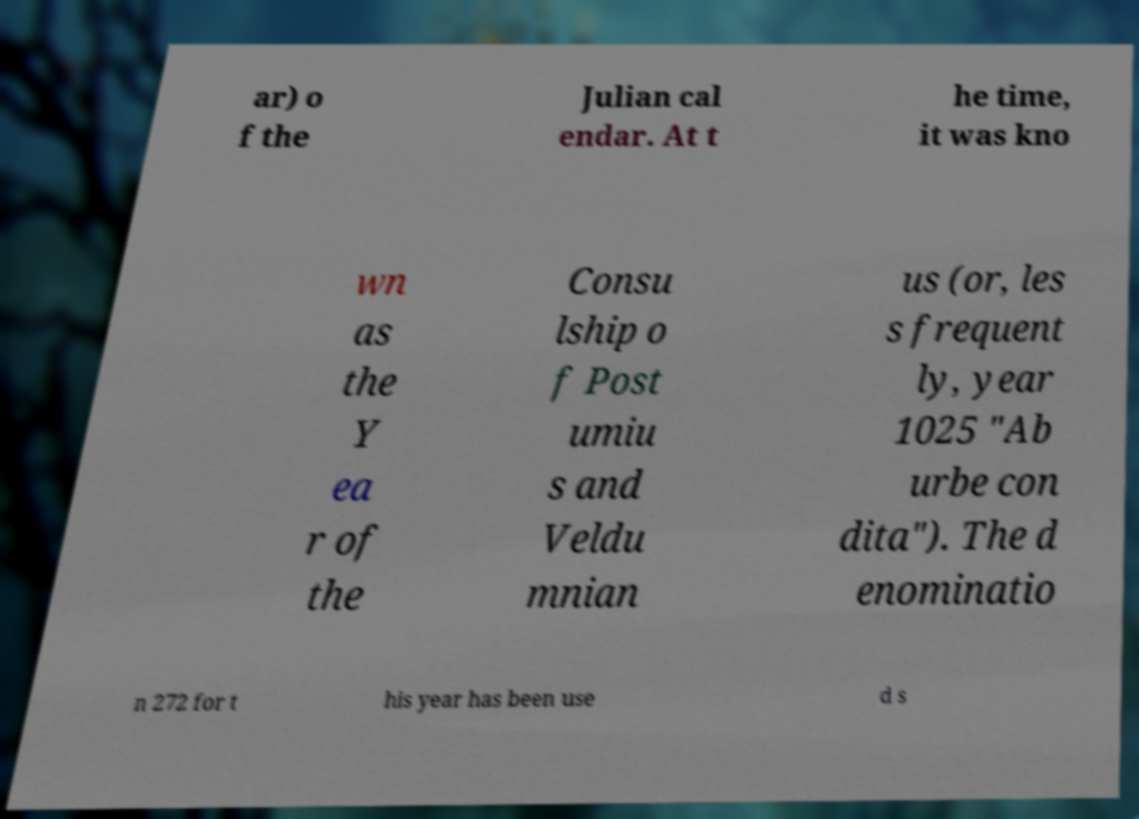Please read and relay the text visible in this image. What does it say? ar) o f the Julian cal endar. At t he time, it was kno wn as the Y ea r of the Consu lship o f Post umiu s and Veldu mnian us (or, les s frequent ly, year 1025 "Ab urbe con dita"). The d enominatio n 272 for t his year has been use d s 